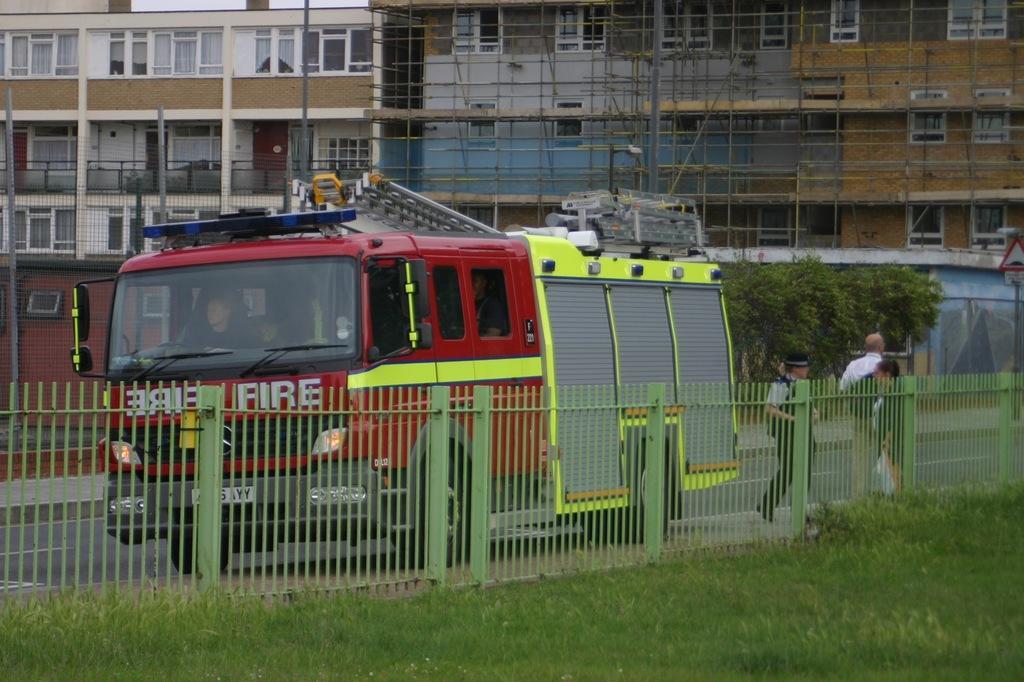How would you summarize this image in a sentence or two? In this picture we can see some people sitting in the fire engine and in front of the fire engine there are some people standing, fence and grass. Behind the fire engine there are trees, poles and a pole with a signboard. Behind the trees there are buildings. 